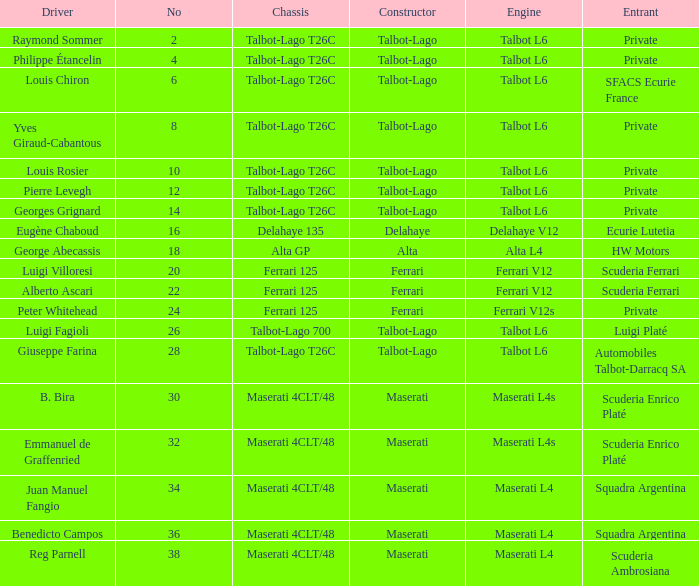Name the chassis for b. bira Maserati 4CLT/48. 